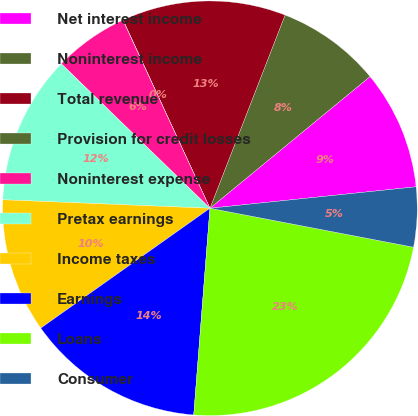<chart> <loc_0><loc_0><loc_500><loc_500><pie_chart><fcel>Net interest income<fcel>Noninterest income<fcel>Total revenue<fcel>Provision for credit losses<fcel>Noninterest expense<fcel>Pretax earnings<fcel>Income taxes<fcel>Earnings<fcel>Loans<fcel>Consumer<nl><fcel>9.3%<fcel>8.14%<fcel>12.78%<fcel>0.02%<fcel>5.82%<fcel>11.62%<fcel>10.46%<fcel>13.94%<fcel>23.23%<fcel>4.66%<nl></chart> 